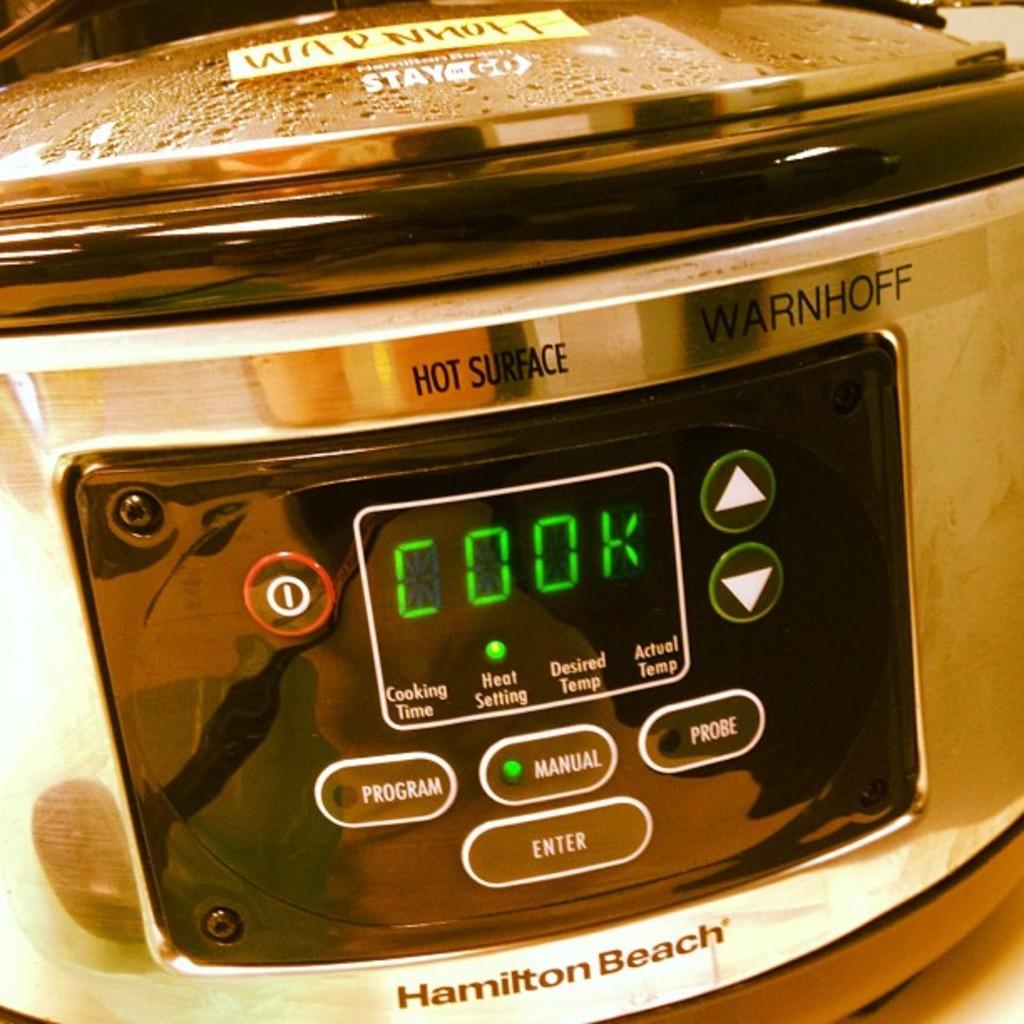What word is shown on the crockpot's display?
Keep it short and to the point. Cook. 